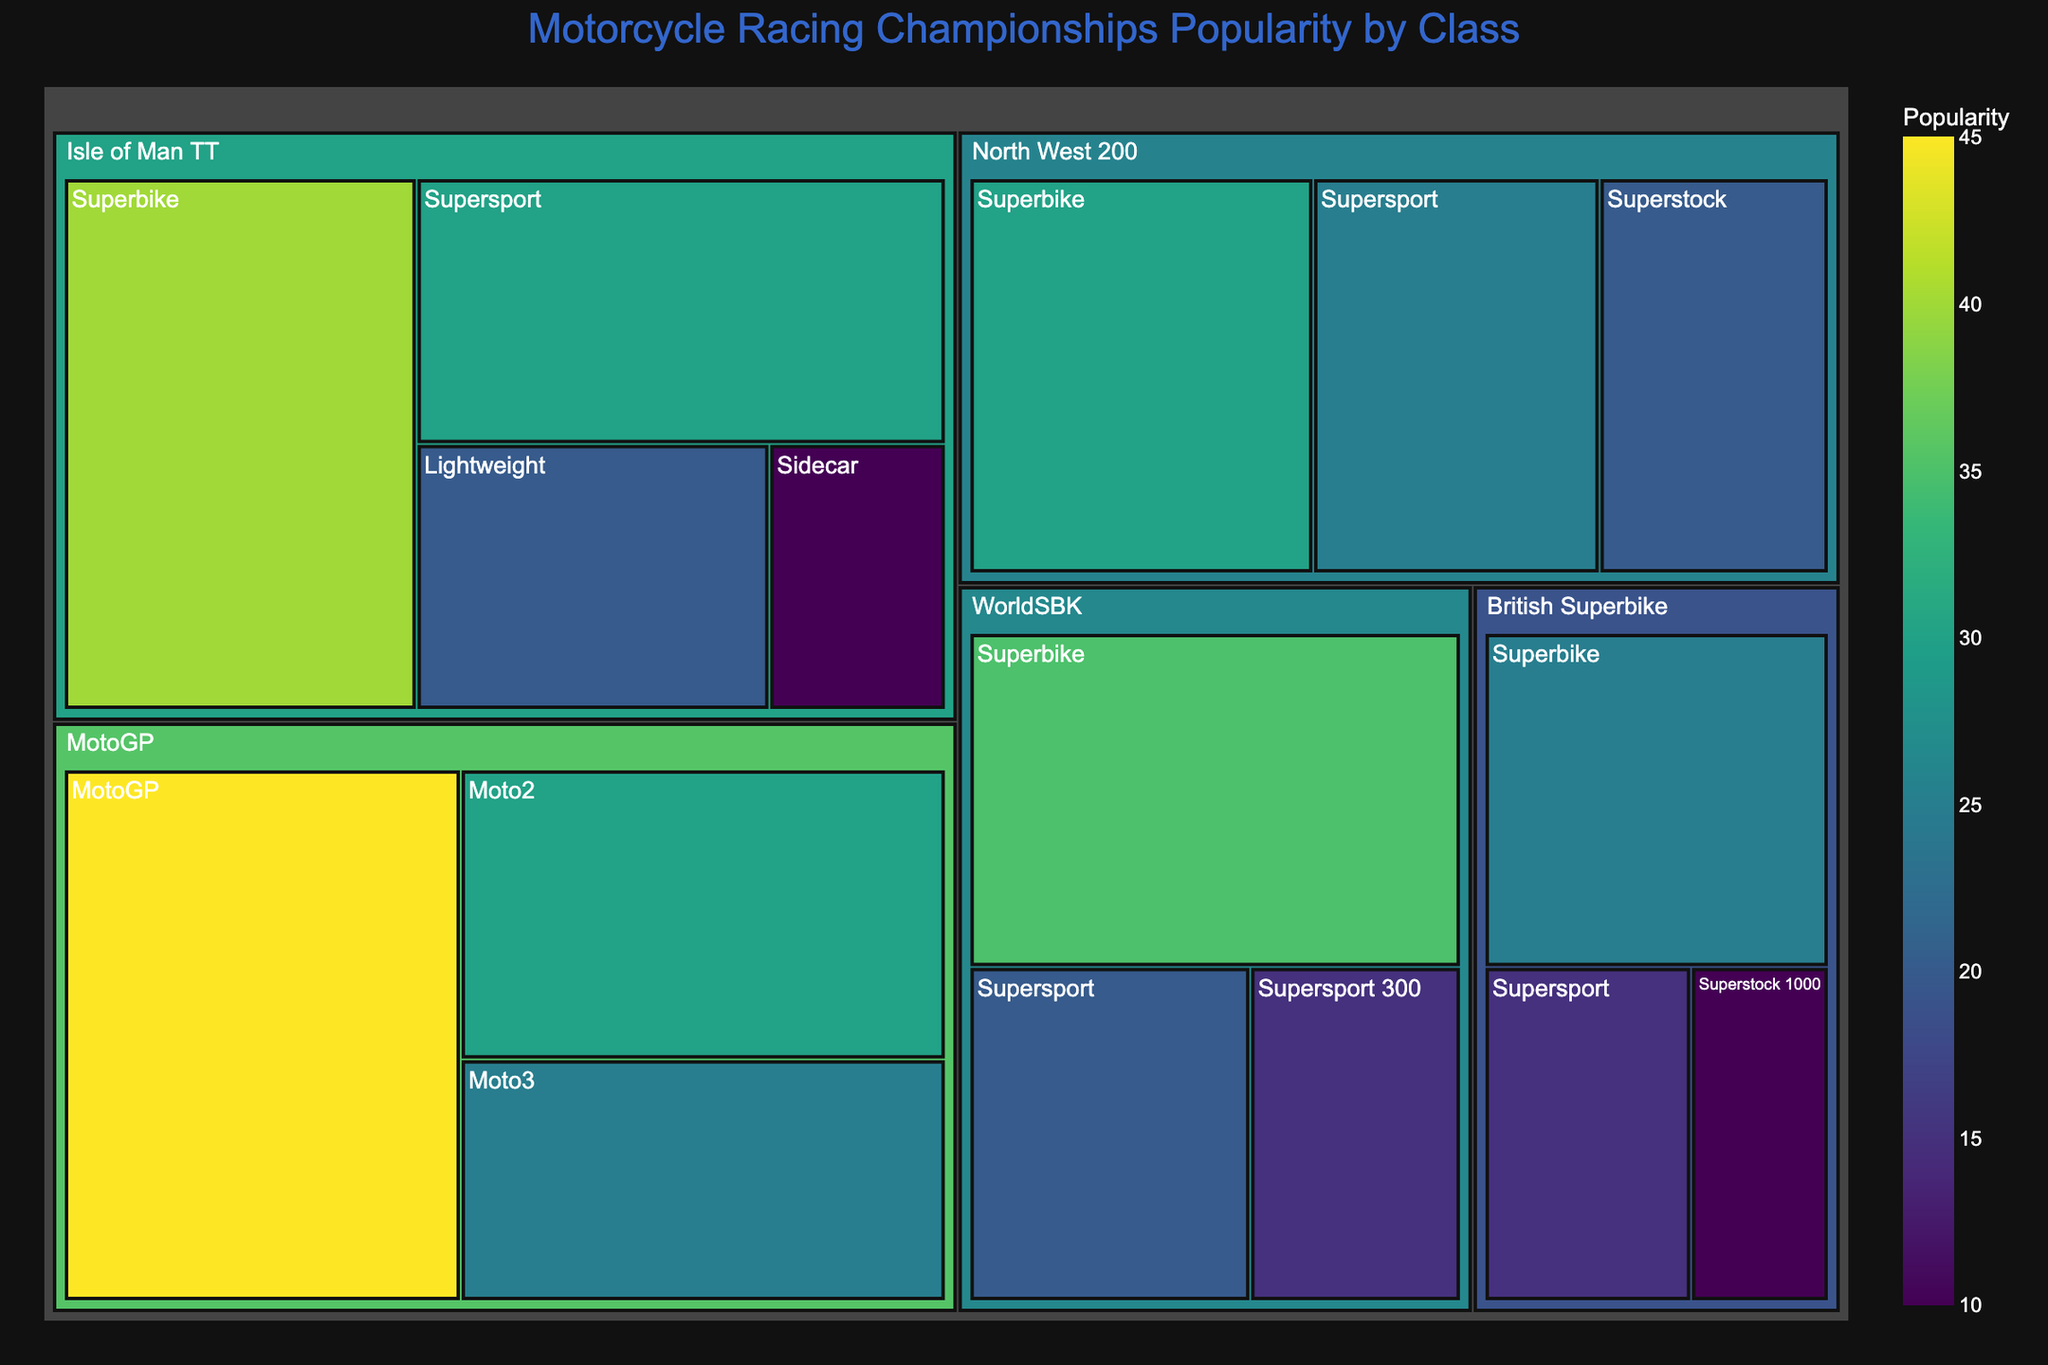what is the title of the figure? The title is usually located at the top of the plot and provides an overview of the chart's content.
Answer: Motorcycle Racing Championships Popularity by Class Which class under the MotoGP championship has the highest popularity? By examining the blocks under the MotoGP category, the class with the largest area signifies the highest popularity.
Answer: MotoGP How many classes are represented in the Isle of Man TT championship? By looking at the Isle of Man TT category, count the number of distinct blocks representing different classes.
Answer: 4 What is the combined popularity for all classes under the British Superbike championship? To find the sum of popuarity under British Superbike: Superbike (25) + Supersport (15) + Superstock 1000 (10).
Answer: 50 Which championship has the least popular class and what is its popularity score? Find the block with the smallest area across all categories and identify its corresponding championship and popularity value.
Answer: Isle of Man TT, Sidecar, 10 Which championship holds the second highest popularity within its most popular class? To determine this, find the highest popularity value for each championship and identify the second largest among those maximum values (MotoGP: 45, WorldSBK: 35, Isle of Man TT: 40, British Superbike: 25, North West 200: 30).
Answer: Isle of Man TT, 40 Compare the popularity of the Superbike class in WorldSBK and Isle of Man TT. Which is more popular? Locate the Superbike class in both WorldSBK and Isle of Man TT and compare their popularity values (WorldSBK: 35, Isle of Man TT: 40).
Answer: Isle of Man TT What is the difference in popularity between the most popular and the least popular classes in the North West 200 championship? Subtract the popularity value of the least popular class from the most popular class within North West 200 (Superbike: 30, Superstock: 20).
Answer: 10 What is the total number of classes represented across all championships? Sum the unique classes by counting each distinct block across all championships.
Answer: 14 Which class under the WorldSBK championship has the lowest popularity? Identify the smallest block within the WorldSBK category representing the class with the lowest popularity.
Answer: Supersport 300 